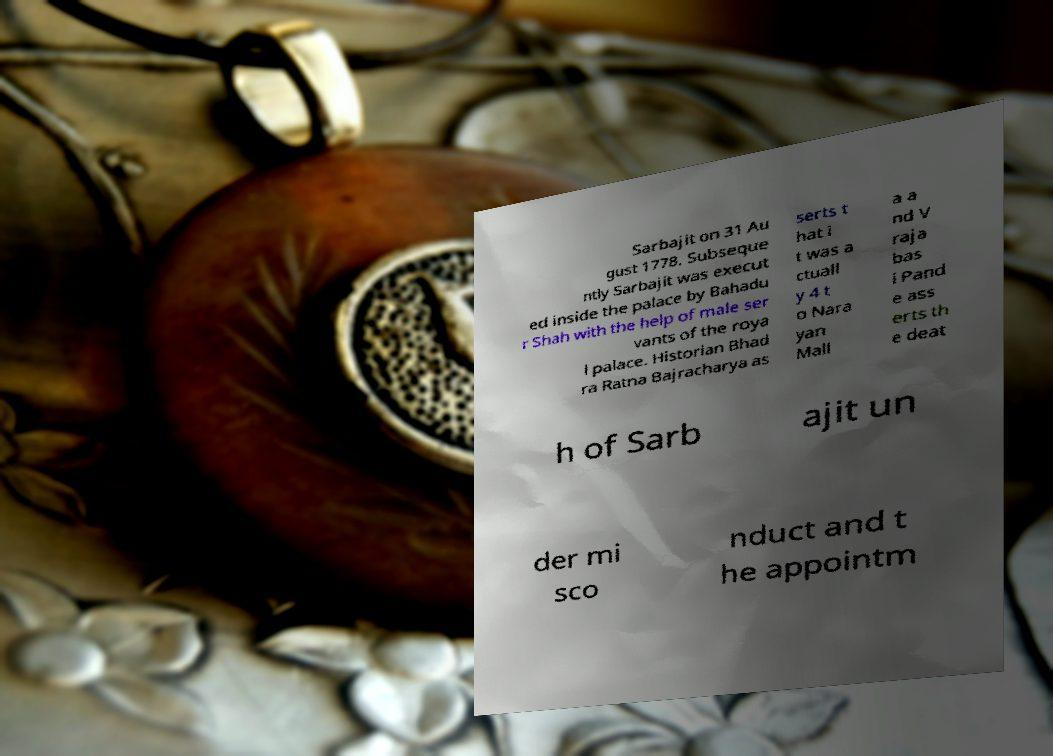Can you accurately transcribe the text from the provided image for me? Sarbajit on 31 Au gust 1778. Subseque ntly Sarbajit was execut ed inside the palace by Bahadu r Shah with the help of male ser vants of the roya l palace. Historian Bhad ra Ratna Bajracharya as serts t hat i t was a ctuall y 4 t o Nara yan Mall a a nd V raja bas i Pand e ass erts th e deat h of Sarb ajit un der mi sco nduct and t he appointm 